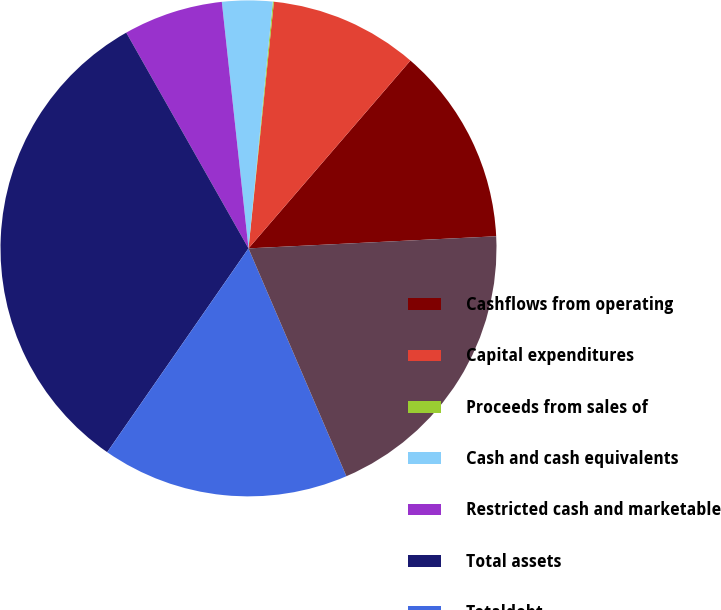Convert chart. <chart><loc_0><loc_0><loc_500><loc_500><pie_chart><fcel>Cashflows from operating<fcel>Capital expenditures<fcel>Proceeds from sales of<fcel>Cash and cash equivalents<fcel>Restricted cash and marketable<fcel>Total assets<fcel>Totaldebt<fcel>Total stockholders' equity<nl><fcel>12.9%<fcel>9.69%<fcel>0.07%<fcel>3.28%<fcel>6.49%<fcel>32.15%<fcel>16.11%<fcel>19.32%<nl></chart> 